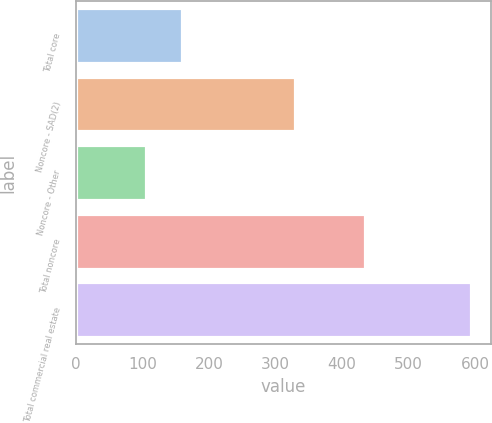<chart> <loc_0><loc_0><loc_500><loc_500><bar_chart><fcel>Total core<fcel>Noncore - SAD(2)<fcel>Noncore - Other<fcel>Total noncore<fcel>Total commercial real estate<nl><fcel>160<fcel>329<fcel>105<fcel>434<fcel>594<nl></chart> 